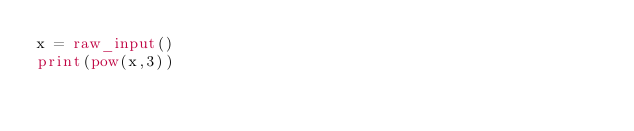Convert code to text. <code><loc_0><loc_0><loc_500><loc_500><_Python_>x = raw_input()
print(pow(x,3))</code> 